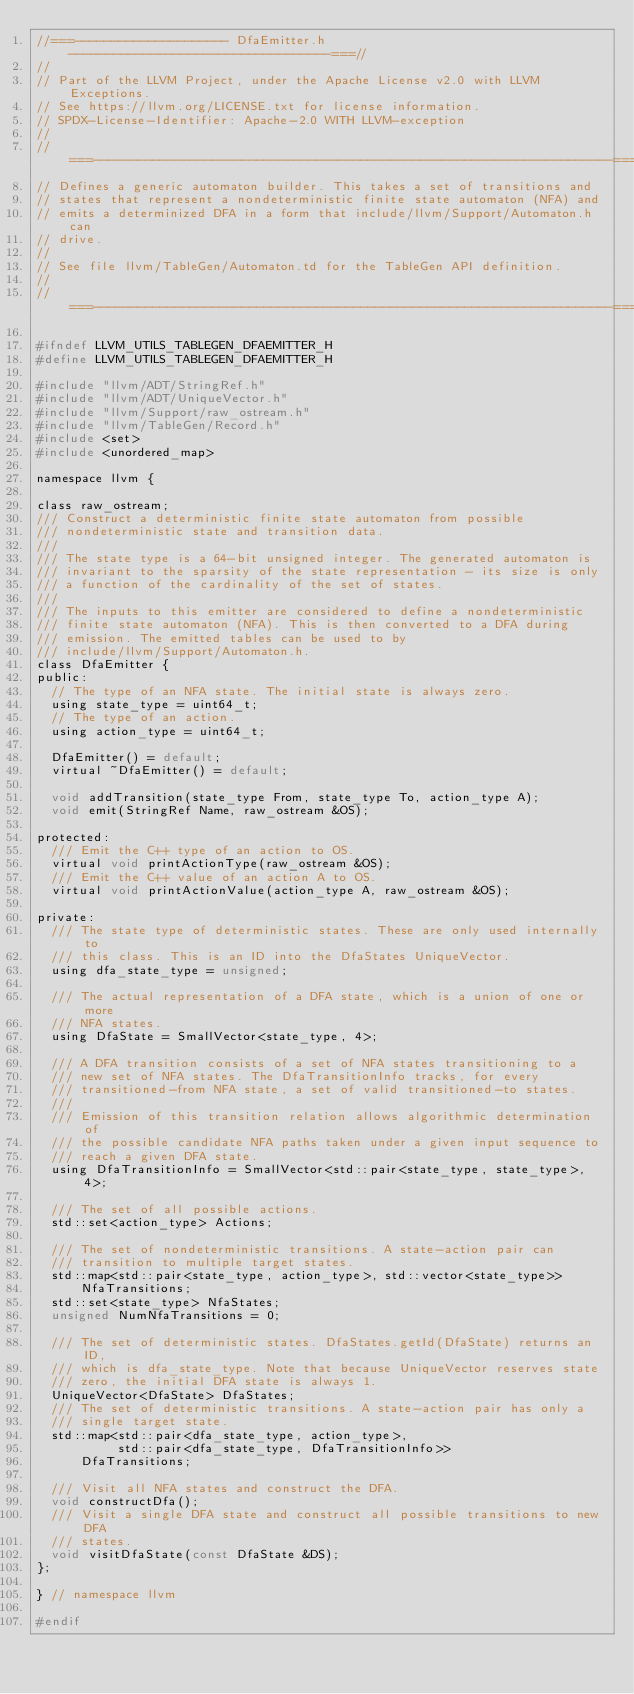<code> <loc_0><loc_0><loc_500><loc_500><_C_>//===--------------------- DfaEmitter.h -----------------------------------===//
//
// Part of the LLVM Project, under the Apache License v2.0 with LLVM Exceptions.
// See https://llvm.org/LICENSE.txt for license information.
// SPDX-License-Identifier: Apache-2.0 WITH LLVM-exception
//
//===----------------------------------------------------------------------===//
// Defines a generic automaton builder. This takes a set of transitions and
// states that represent a nondeterministic finite state automaton (NFA) and
// emits a determinized DFA in a form that include/llvm/Support/Automaton.h can
// drive.
//
// See file llvm/TableGen/Automaton.td for the TableGen API definition.
//
//===----------------------------------------------------------------------===//

#ifndef LLVM_UTILS_TABLEGEN_DFAEMITTER_H
#define LLVM_UTILS_TABLEGEN_DFAEMITTER_H

#include "llvm/ADT/StringRef.h"
#include "llvm/ADT/UniqueVector.h"
#include "llvm/Support/raw_ostream.h"
#include "llvm/TableGen/Record.h"
#include <set>
#include <unordered_map>

namespace llvm {

class raw_ostream;
/// Construct a deterministic finite state automaton from possible
/// nondeterministic state and transition data.
///
/// The state type is a 64-bit unsigned integer. The generated automaton is
/// invariant to the sparsity of the state representation - its size is only
/// a function of the cardinality of the set of states.
///
/// The inputs to this emitter are considered to define a nondeterministic
/// finite state automaton (NFA). This is then converted to a DFA during
/// emission. The emitted tables can be used to by
/// include/llvm/Support/Automaton.h.
class DfaEmitter {
public:
  // The type of an NFA state. The initial state is always zero.
  using state_type = uint64_t;
  // The type of an action.
  using action_type = uint64_t;

  DfaEmitter() = default;
  virtual ~DfaEmitter() = default;

  void addTransition(state_type From, state_type To, action_type A);
  void emit(StringRef Name, raw_ostream &OS);

protected:
  /// Emit the C++ type of an action to OS.
  virtual void printActionType(raw_ostream &OS);
  /// Emit the C++ value of an action A to OS.
  virtual void printActionValue(action_type A, raw_ostream &OS);

private:
  /// The state type of deterministic states. These are only used internally to
  /// this class. This is an ID into the DfaStates UniqueVector.
  using dfa_state_type = unsigned;

  /// The actual representation of a DFA state, which is a union of one or more
  /// NFA states.
  using DfaState = SmallVector<state_type, 4>;

  /// A DFA transition consists of a set of NFA states transitioning to a
  /// new set of NFA states. The DfaTransitionInfo tracks, for every
  /// transitioned-from NFA state, a set of valid transitioned-to states.
  ///
  /// Emission of this transition relation allows algorithmic determination of
  /// the possible candidate NFA paths taken under a given input sequence to
  /// reach a given DFA state.
  using DfaTransitionInfo = SmallVector<std::pair<state_type, state_type>, 4>;

  /// The set of all possible actions.
  std::set<action_type> Actions;

  /// The set of nondeterministic transitions. A state-action pair can
  /// transition to multiple target states.
  std::map<std::pair<state_type, action_type>, std::vector<state_type>>
      NfaTransitions;
  std::set<state_type> NfaStates;
  unsigned NumNfaTransitions = 0;

  /// The set of deterministic states. DfaStates.getId(DfaState) returns an ID,
  /// which is dfa_state_type. Note that because UniqueVector reserves state
  /// zero, the initial DFA state is always 1.
  UniqueVector<DfaState> DfaStates;
  /// The set of deterministic transitions. A state-action pair has only a
  /// single target state.
  std::map<std::pair<dfa_state_type, action_type>,
           std::pair<dfa_state_type, DfaTransitionInfo>>
      DfaTransitions;

  /// Visit all NFA states and construct the DFA.
  void constructDfa();
  /// Visit a single DFA state and construct all possible transitions to new DFA
  /// states.
  void visitDfaState(const DfaState &DS);
};

} // namespace llvm

#endif
</code> 